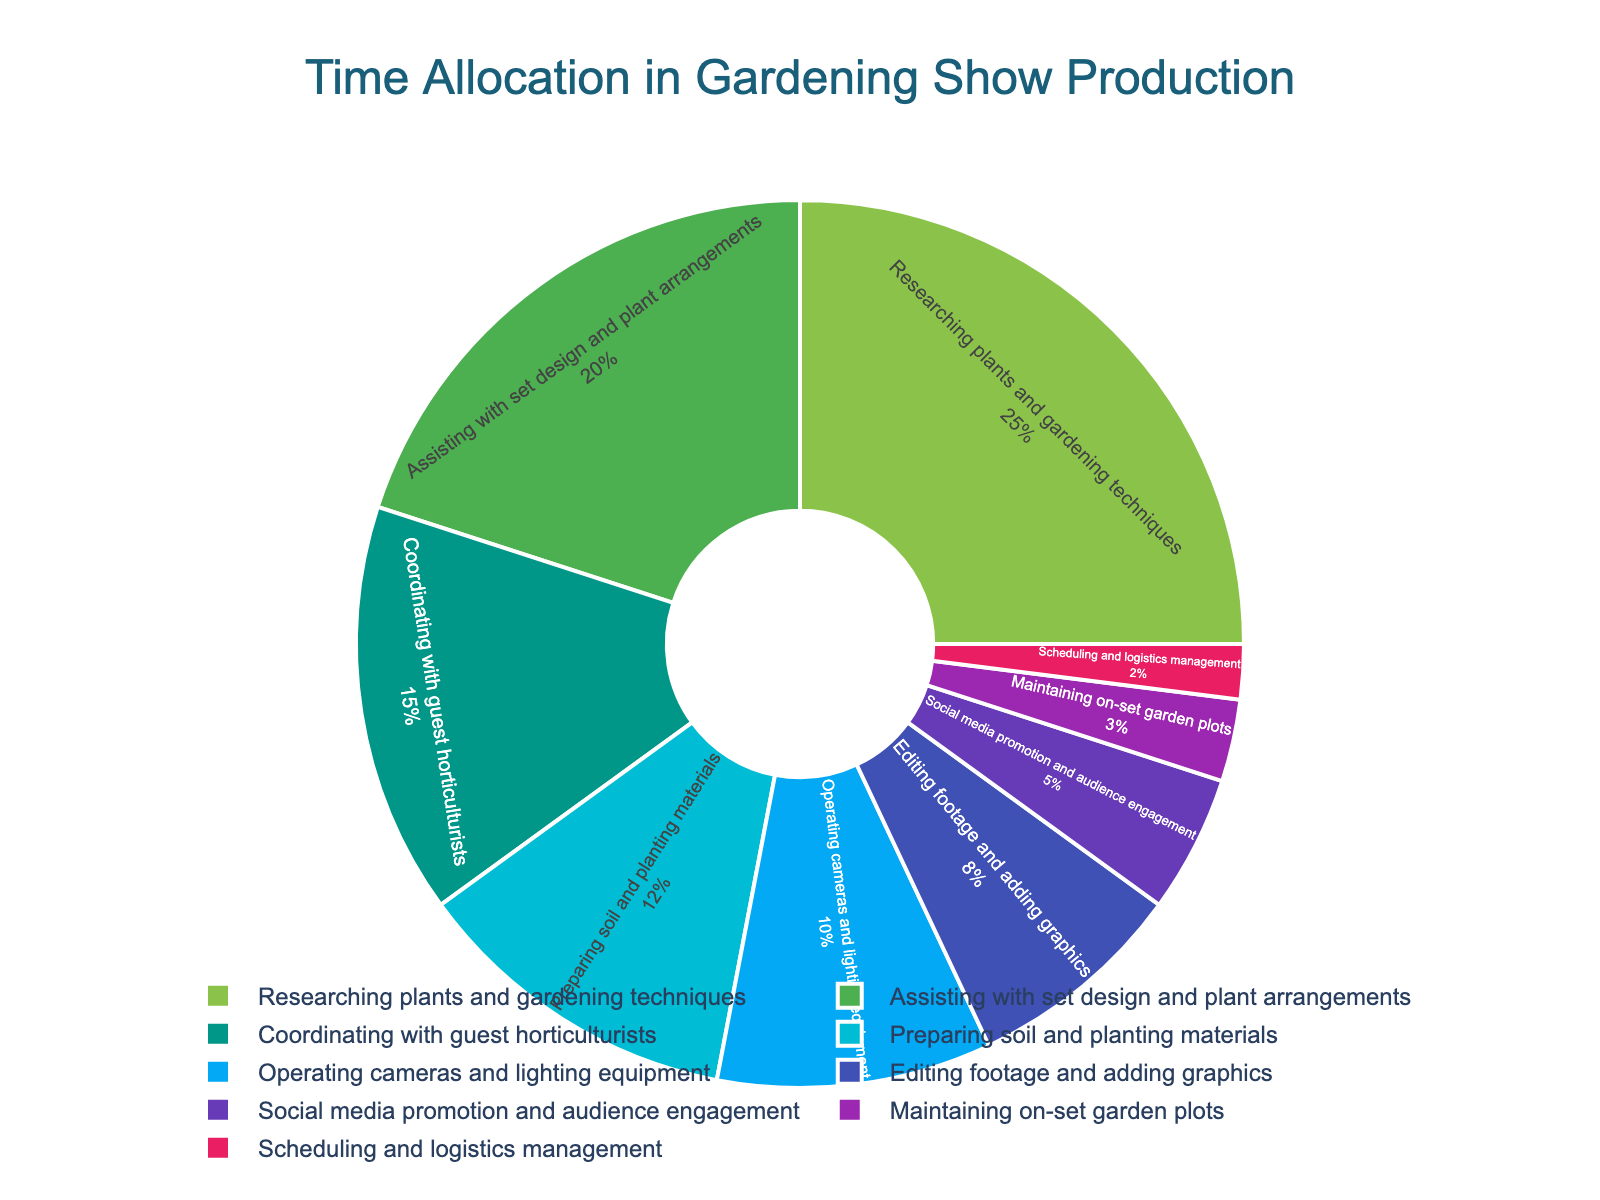What's the largest task percentage in the pie chart? The largest percentage in the pie chart is the one with the highest value among all the segments. The "Researching plants and gardening techniques" task has the highest percentage at 25%.
Answer: 25% Which tasks are allocated less than 10% of the time? Tasks allocated less than 10% are those with percentages below 10%. The tasks are "Editing footage and adding graphics" (8%), "Social media promotion and audience engagement" (5%), "Maintaining on-set garden plots" (3%), and "Scheduling and logistics management" (2%).
Answer: Four tasks How much more time is spent on "Researching plants and gardening techniques" compared to "Preparing soil and planting materials"? To find the difference, subtract the percentage of "Preparing soil and planting materials" from "Researching plants and gardening techniques": 25% - 12% = 13%.
Answer: 13% What percentage of time is allocated to operating technical equipment (cameras and lighting)? The percentage allocated to "Operating cameras and lighting equipment" can be directly read from the pie chart, which is 10%.
Answer: 10% What is the combined percentage of "Coordinating with guest horticulturists" and "Assisting with set design and plant arrangements"? To find the combined percentage, add the two values: 15% (Coordinating with guest horticulturists) + 20% (Assisting with set design and plant arrangements) = 35%.
Answer: 35% Which task is represented by the smallest segment in the pie chart? The smallest segment in the pie chart corresponds to the task with the lowest percentage, which is "Scheduling and logistics management" at 2%.
Answer: Scheduling and logistics management Do "Researching plants and gardening techniques" and "Assisting with set design and plant arrangements" together account for more than 40% of the time? Add the percentages of the two tasks: 25% (Researching plants and gardening techniques) + 20% (Assisting with set design and plant arrangements) = 45%, which is more than 40%.
Answer: Yes Which color in the pie chart represents "Operating cameras and lighting equipment"? The pie chart uses specific colors for each task. "Operating cameras and lighting equipment" is represented by the color light blue.
Answer: Light blue What is the average percentage of the three largest task allocations? The three largest tasks are "Researching plants and gardening techniques" (25%), "Assisting with set design and plant arrangements" (20%), and "Coordinating with guest horticulturists" (15%). The average is calculated as (25% + 20% + 15%) / 3 = 20%.
Answer: 20% Which task takes up more time, "Editing footage and adding graphics" or "Maintaining on-set garden plots"? Compare the percentages: "Editing footage and adding graphics" is 8%, whereas "Maintaining on-set garden plots" is 3%. Since 8% > 3%, "Editing footage and adding graphics" takes up more time.
Answer: Editing footage and adding graphics 